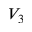<formula> <loc_0><loc_0><loc_500><loc_500>V _ { 3 }</formula> 